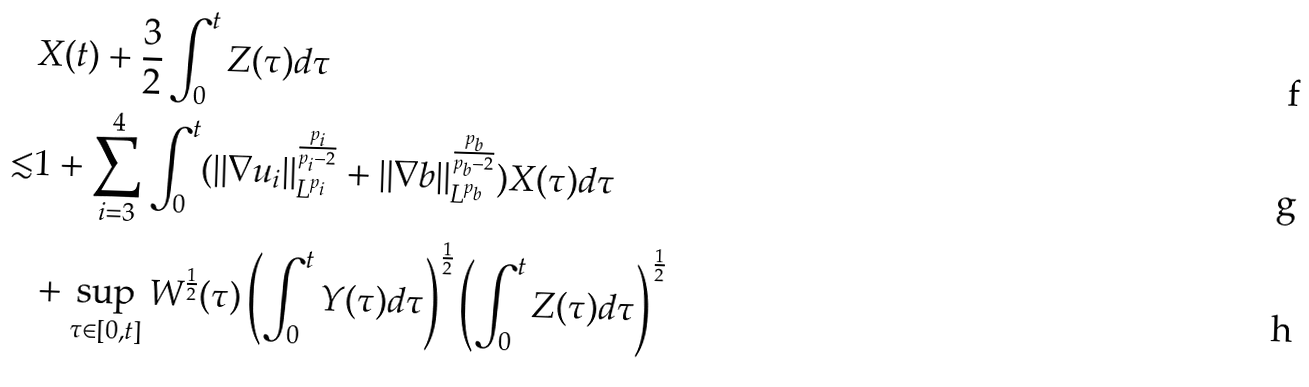Convert formula to latex. <formula><loc_0><loc_0><loc_500><loc_500>& X ( t ) + \frac { 3 } { 2 } \int _ { 0 } ^ { t } Z ( \tau ) d \tau \\ \lesssim & 1 + \sum _ { i = 3 } ^ { 4 } \int _ { 0 } ^ { t } ( \| \nabla u _ { i } \| _ { L ^ { p _ { i } } } ^ { \frac { p _ { i } } { p _ { i } - 2 } } + \| \nabla b \| _ { L ^ { p _ { b } } } ^ { \frac { p _ { b } } { p _ { b } - 2 } } ) X ( \tau ) d \tau \\ & + \sup _ { \tau \in [ 0 , t ] } W ^ { \frac { 1 } { 2 } } ( \tau ) \left ( \int _ { 0 } ^ { t } Y ( \tau ) d \tau \right ) ^ { \frac { 1 } { 2 } } \left ( \int _ { 0 } ^ { t } Z ( \tau ) d \tau \right ) ^ { \frac { 1 } { 2 } }</formula> 